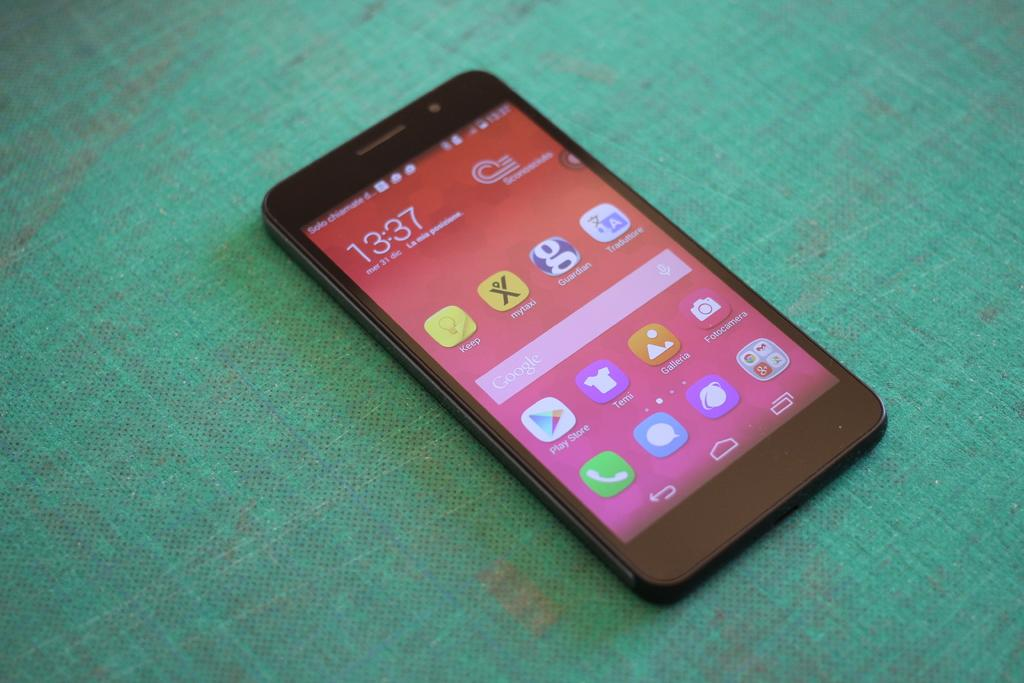<image>
Render a clear and concise summary of the photo. A cell phone that has a screen with a pink background displays the time 13:37. 